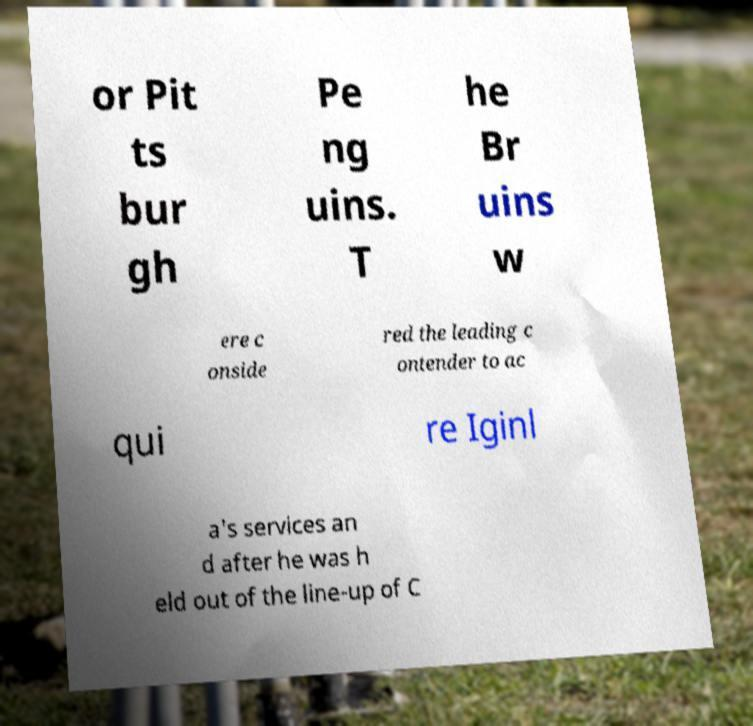Can you accurately transcribe the text from the provided image for me? or Pit ts bur gh Pe ng uins. T he Br uins w ere c onside red the leading c ontender to ac qui re Iginl a's services an d after he was h eld out of the line-up of C 